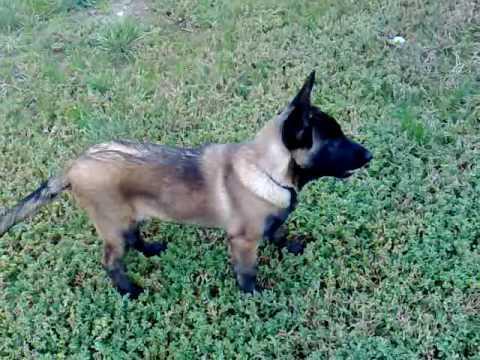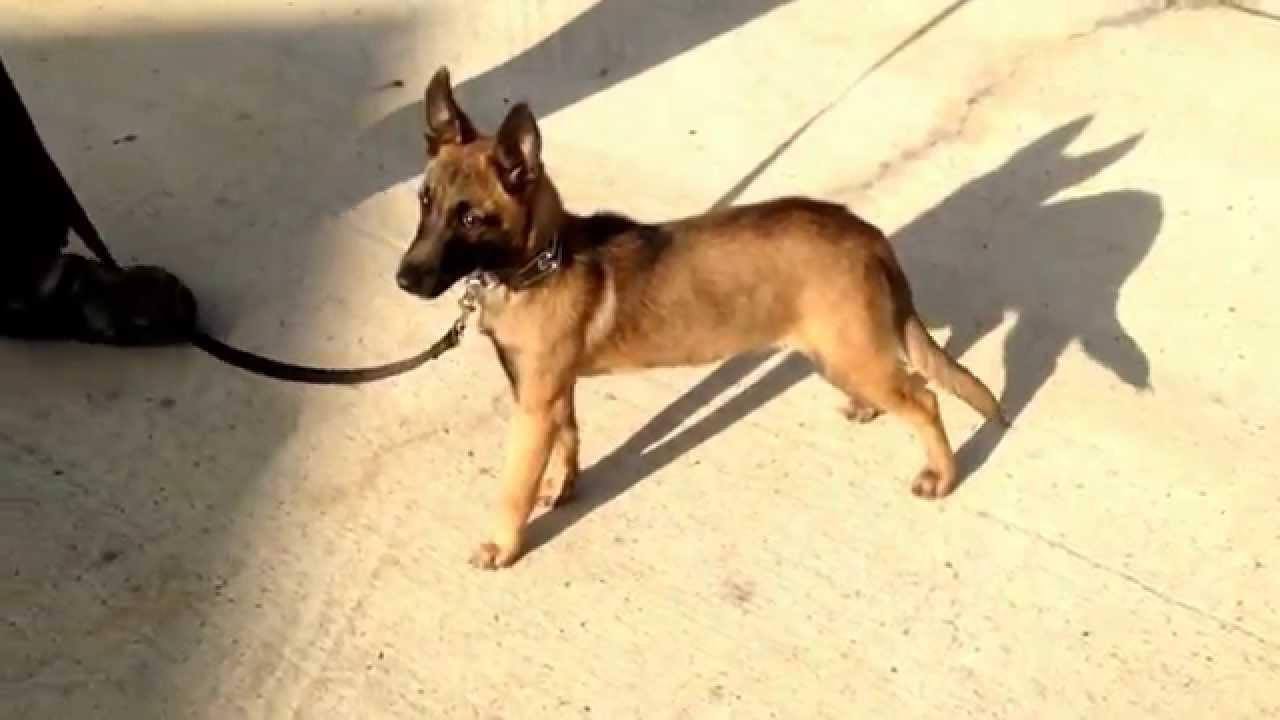The first image is the image on the left, the second image is the image on the right. Given the left and right images, does the statement "An image shows only one dog, which is standing on a hard surface and wearing a leash." hold true? Answer yes or no. Yes. The first image is the image on the left, the second image is the image on the right. Considering the images on both sides, is "There are two dogs in total and one of them is standing on grass.›" valid? Answer yes or no. Yes. 